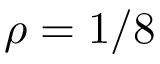<formula> <loc_0><loc_0><loc_500><loc_500>\rho = 1 / 8</formula> 